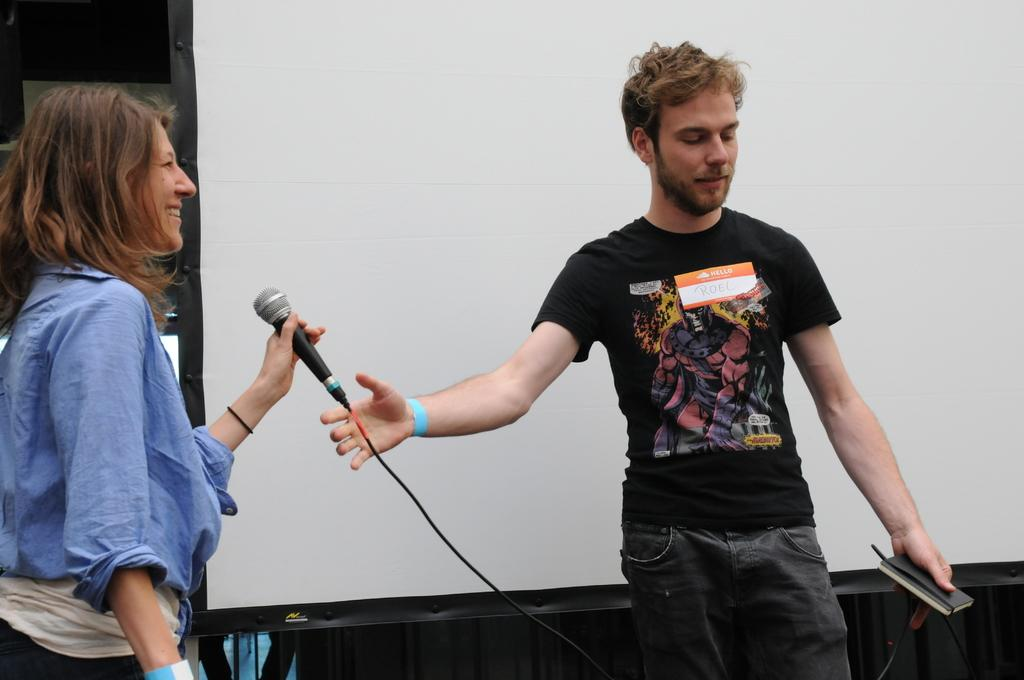Who are the people in the image? There is a man and a woman in the image. What is the woman doing in the image? The woman is laughing in the image. What is the woman holding in the image? The woman is holding a microphone in the image. What can be seen in the background of the image? There is a screen in the background of the image. Can you see a dog in the image? No, there is no dog present in the image. Is there any smoke visible in the image? No, there is no smoke visible in the image. 